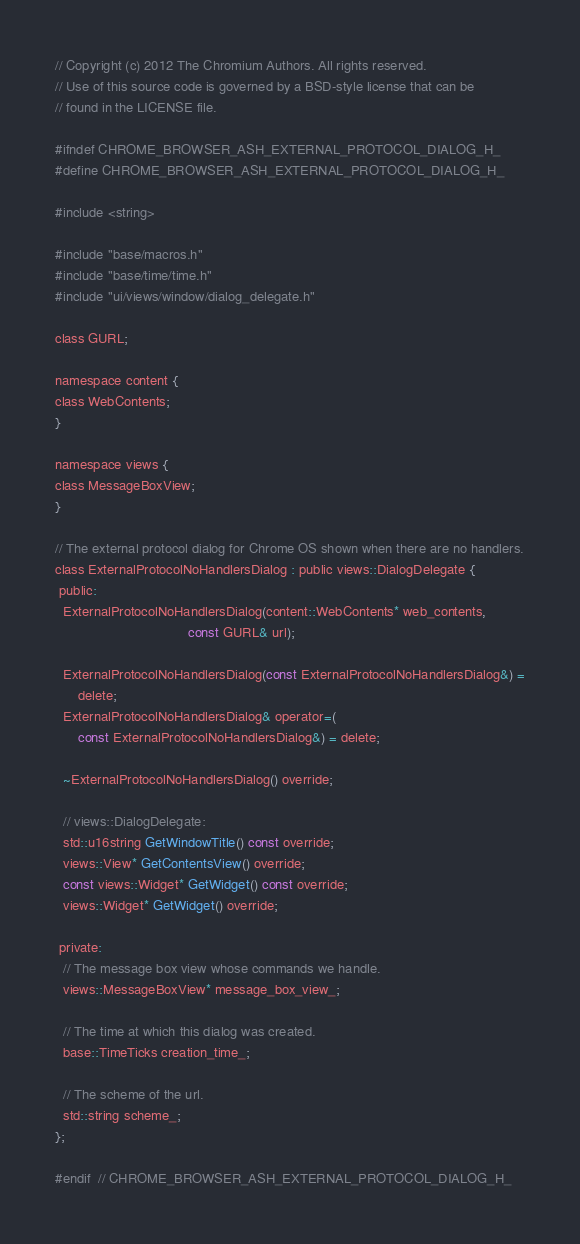<code> <loc_0><loc_0><loc_500><loc_500><_C_>// Copyright (c) 2012 The Chromium Authors. All rights reserved.
// Use of this source code is governed by a BSD-style license that can be
// found in the LICENSE file.

#ifndef CHROME_BROWSER_ASH_EXTERNAL_PROTOCOL_DIALOG_H_
#define CHROME_BROWSER_ASH_EXTERNAL_PROTOCOL_DIALOG_H_

#include <string>

#include "base/macros.h"
#include "base/time/time.h"
#include "ui/views/window/dialog_delegate.h"

class GURL;

namespace content {
class WebContents;
}

namespace views {
class MessageBoxView;
}

// The external protocol dialog for Chrome OS shown when there are no handlers.
class ExternalProtocolNoHandlersDialog : public views::DialogDelegate {
 public:
  ExternalProtocolNoHandlersDialog(content::WebContents* web_contents,
                                   const GURL& url);

  ExternalProtocolNoHandlersDialog(const ExternalProtocolNoHandlersDialog&) =
      delete;
  ExternalProtocolNoHandlersDialog& operator=(
      const ExternalProtocolNoHandlersDialog&) = delete;

  ~ExternalProtocolNoHandlersDialog() override;

  // views::DialogDelegate:
  std::u16string GetWindowTitle() const override;
  views::View* GetContentsView() override;
  const views::Widget* GetWidget() const override;
  views::Widget* GetWidget() override;

 private:
  // The message box view whose commands we handle.
  views::MessageBoxView* message_box_view_;

  // The time at which this dialog was created.
  base::TimeTicks creation_time_;

  // The scheme of the url.
  std::string scheme_;
};

#endif  // CHROME_BROWSER_ASH_EXTERNAL_PROTOCOL_DIALOG_H_
</code> 